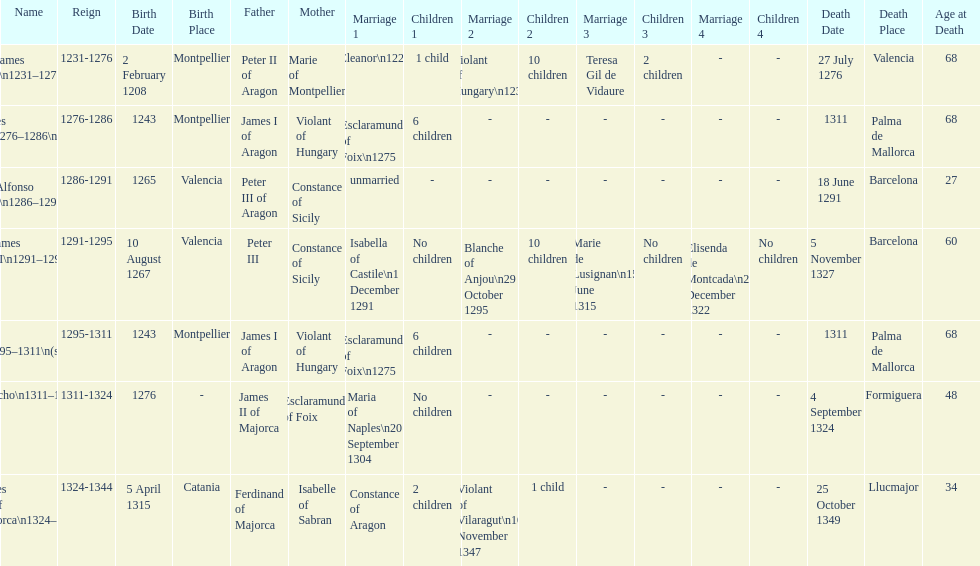James i and james ii both died at what age? 68. 